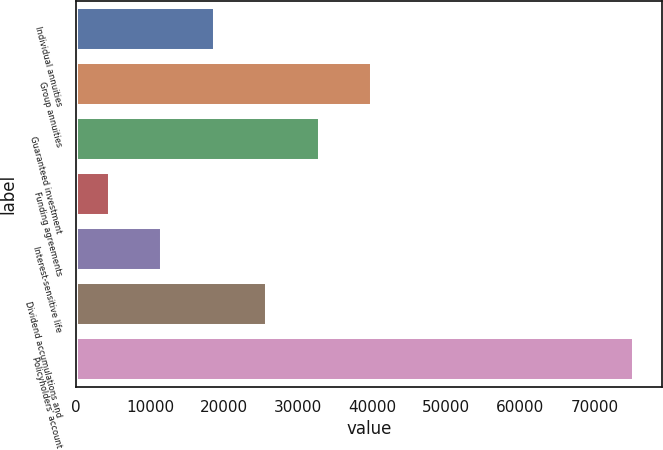Convert chart to OTSL. <chart><loc_0><loc_0><loc_500><loc_500><bar_chart><fcel>Individual annuities<fcel>Group annuities<fcel>Guaranteed investment<fcel>Funding agreements<fcel>Interest-sensitive life<fcel>Dividend accumulations and<fcel>Policyholders' account<nl><fcel>18701.2<fcel>39950.5<fcel>32867.4<fcel>4535<fcel>11618.1<fcel>25784.3<fcel>75366<nl></chart> 